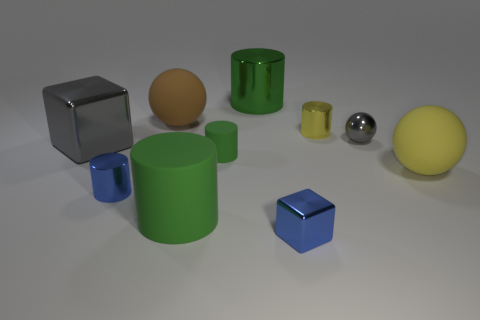How many green cylinders must be subtracted to get 1 green cylinders? 2 Subtract all yellow cubes. How many green cylinders are left? 3 Subtract all large spheres. How many spheres are left? 1 Subtract 1 cylinders. How many cylinders are left? 4 Subtract all blue cylinders. How many cylinders are left? 4 Subtract all blue balls. Subtract all purple cylinders. How many balls are left? 3 Subtract all blocks. How many objects are left? 8 Add 1 rubber cylinders. How many rubber cylinders are left? 3 Add 9 big purple metallic cubes. How many big purple metallic cubes exist? 9 Subtract 0 yellow blocks. How many objects are left? 10 